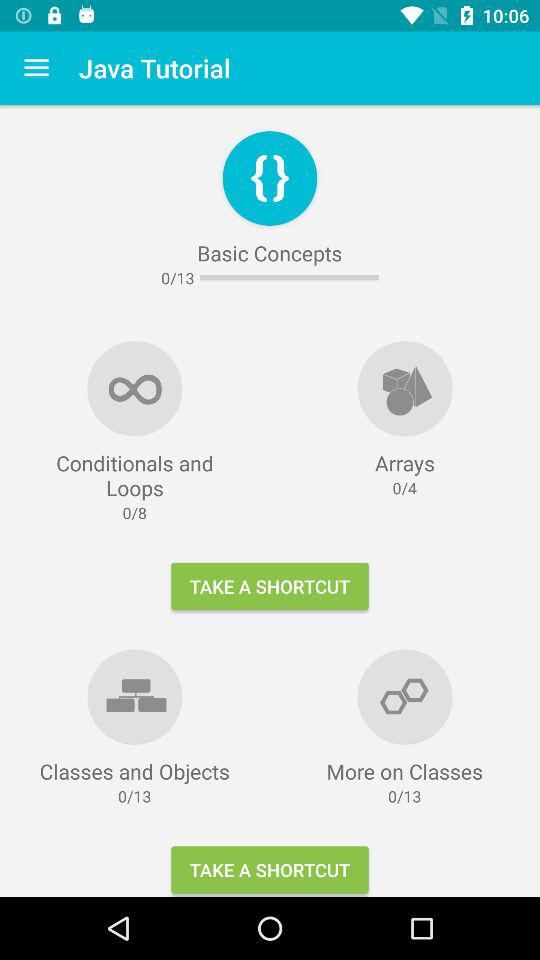At which Basic concept I am at?
When the provided information is insufficient, respond with <no answer>. <no answer> 